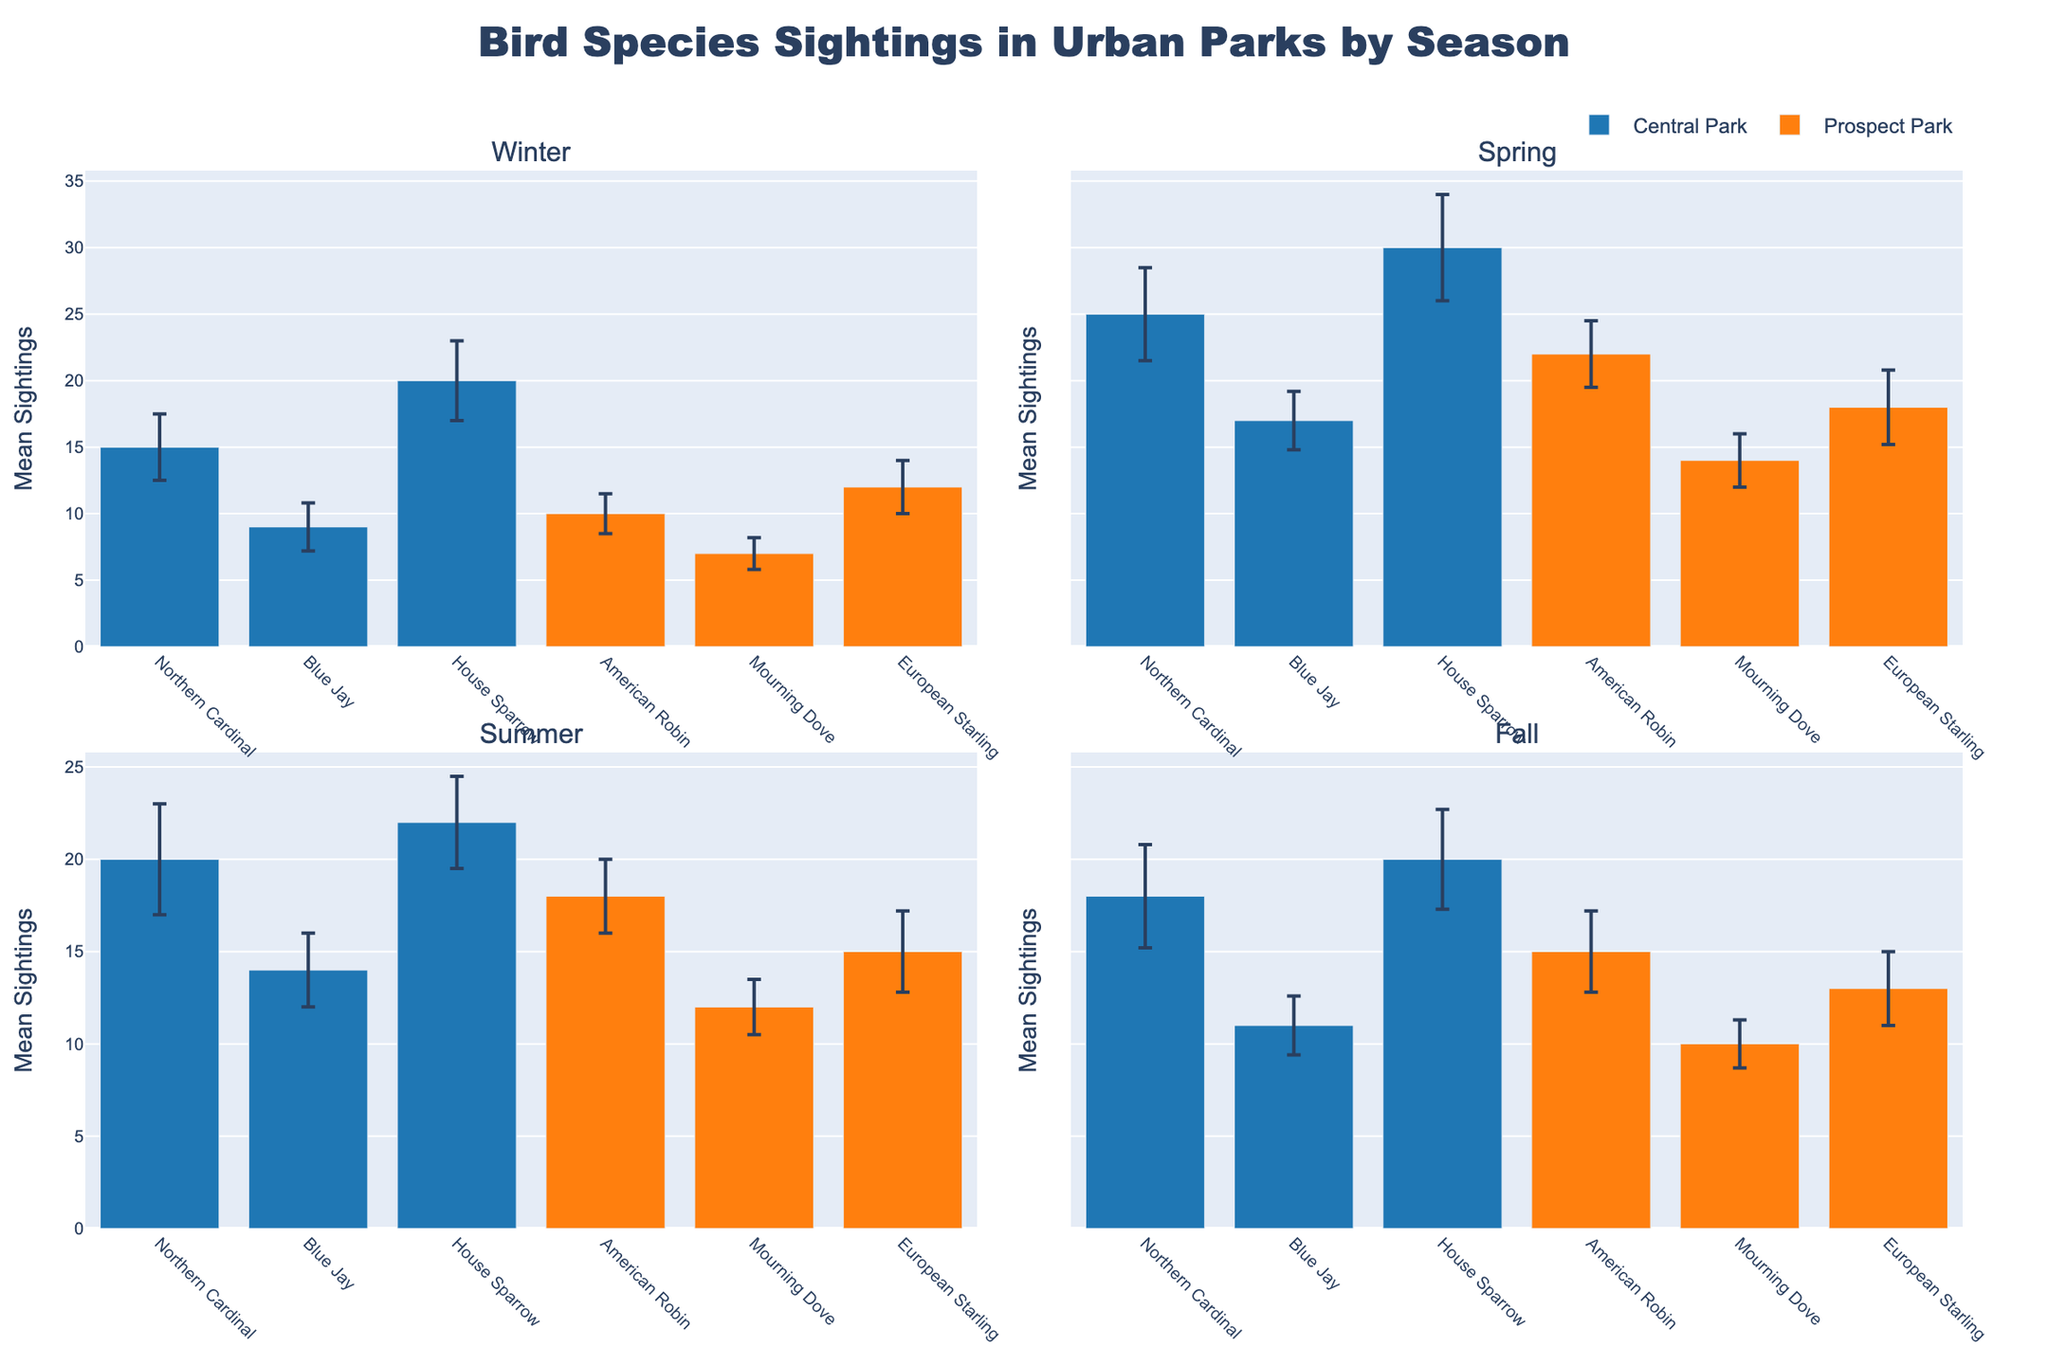How many bird species are shown for Central Park in Winter? In the subplot for Winter, look at the x-axis labels for Central Park. There are three species: Northern Cardinal, Blue Jay, and House Sparrow
Answer: Three What is the average mean sightings of European Starling in Prospect Park across all seasons? The mean sightings in Winter is 12, in Spring is 18, in Summer is 15, and in Fall is 13. The average is calculated as (12 + 18 + 15 + 13) / 4 = 14.5
Answer: 14.5 Which season shows the highest mean sightings for Northern Cardinal in Central Park? Look at the mean sightings for Northern Cardinal in Central Park across all subplots. The highest mean is 25 in Spring.
Answer: Spring Are the mean sightings of Blue Jay in Central Park higher in Spring or Summer? Compare the height of the bars for Blue Jay in Central Park between Spring and Summer subplots. Spring has a higher mean (17) compared to Summer (14).
Answer: Spring What is the total mean sightings of House Sparrow in Central Park for the year? Add the mean sightings of House Sparrow across all seasons in Central Park: Winter (20), Spring (30), Summer (22), and Fall (20). Total is 20 + 30 + 22 + 20 = 92
Answer: 92 Which park has more sightings of American Robin in Summer? Compare the heights of the bars for American Robin in Prospect Park and Central Park in the Summer subplot. Prospect Park has 18 mean sightings, and Central Park does not have this species listed.
Answer: Prospect Park What is the difference in mean sightings of Mourning Dove between Winter and Fall in Prospect Park? The mean sightings in Winter is 7, and in Fall is 10. The difference is calculated as 10 - 7 = 3.
Answer: 3 In which season is the variability (standard deviation) for Northern Cardinal sightings the highest in Central Park? Look at the length of the error bars for Northern Cardinal in Central Park across all subplots. Spring has the longest error bar, indicating higher variability (3.5).
Answer: Spring 